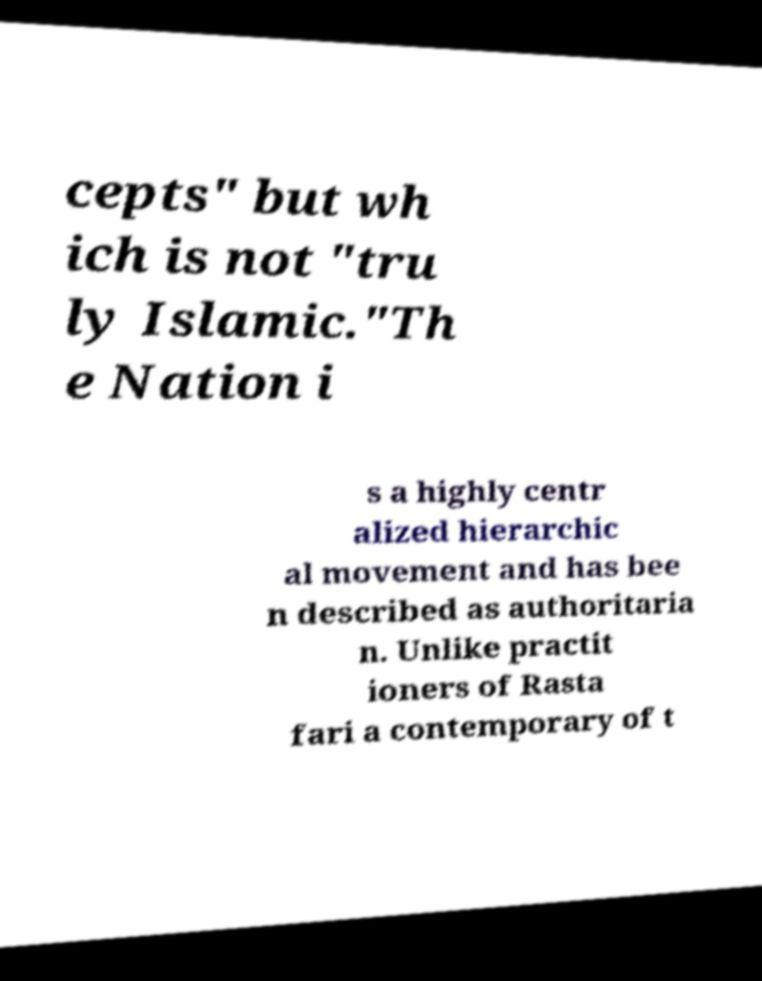What messages or text are displayed in this image? I need them in a readable, typed format. cepts" but wh ich is not "tru ly Islamic."Th e Nation i s a highly centr alized hierarchic al movement and has bee n described as authoritaria n. Unlike practit ioners of Rasta fari a contemporary of t 